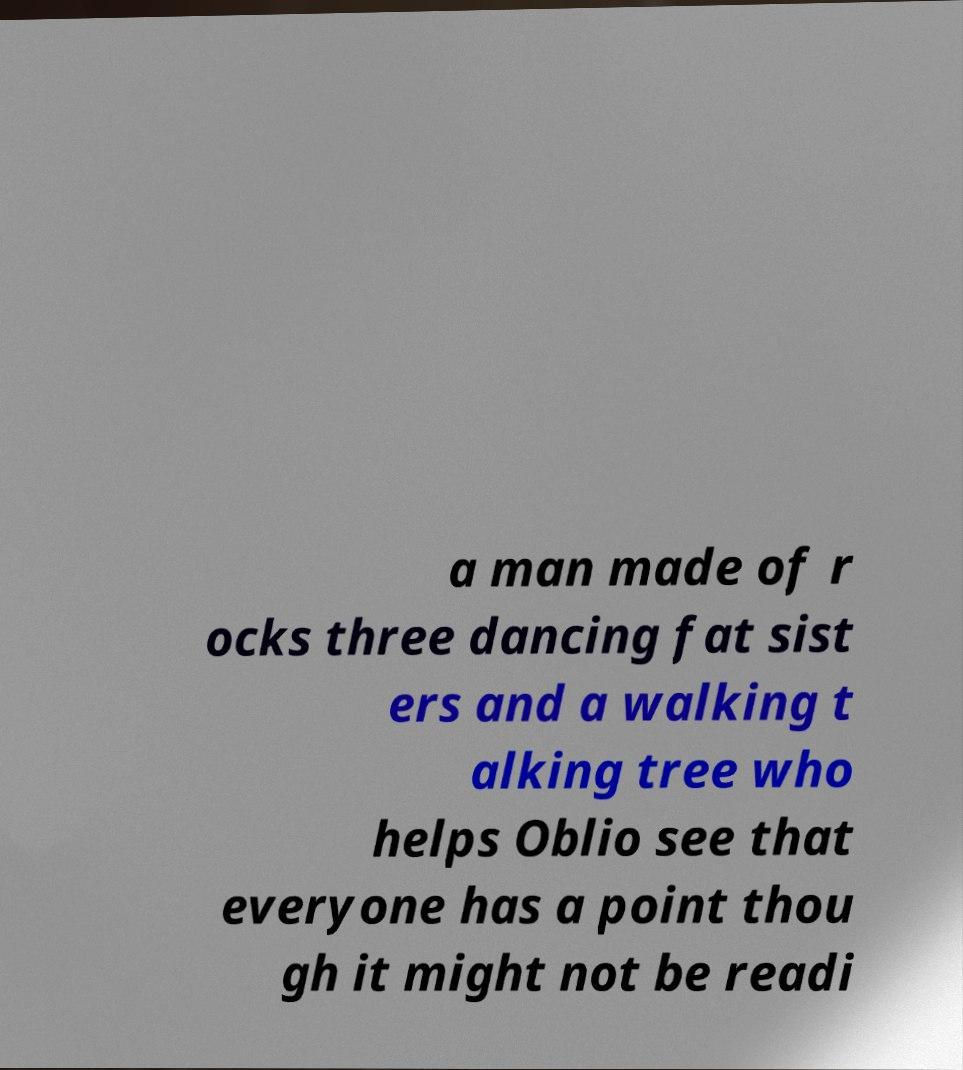Can you accurately transcribe the text from the provided image for me? a man made of r ocks three dancing fat sist ers and a walking t alking tree who helps Oblio see that everyone has a point thou gh it might not be readi 